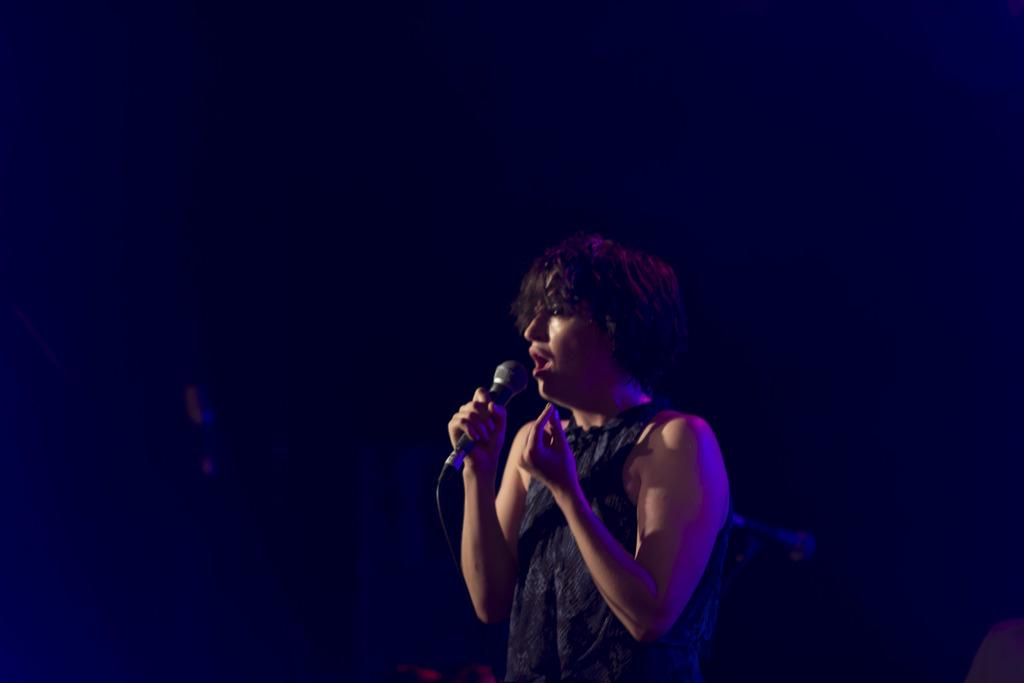What is the main subject of the image? There is a person in the image. What is the person holding in the image? The person is holding a microphone. What color is the background of the image? The background of the image is black in color. What type of advertisement can be seen in the image? There is no advertisement present in the image; it features a person holding a microphone against a black background. 